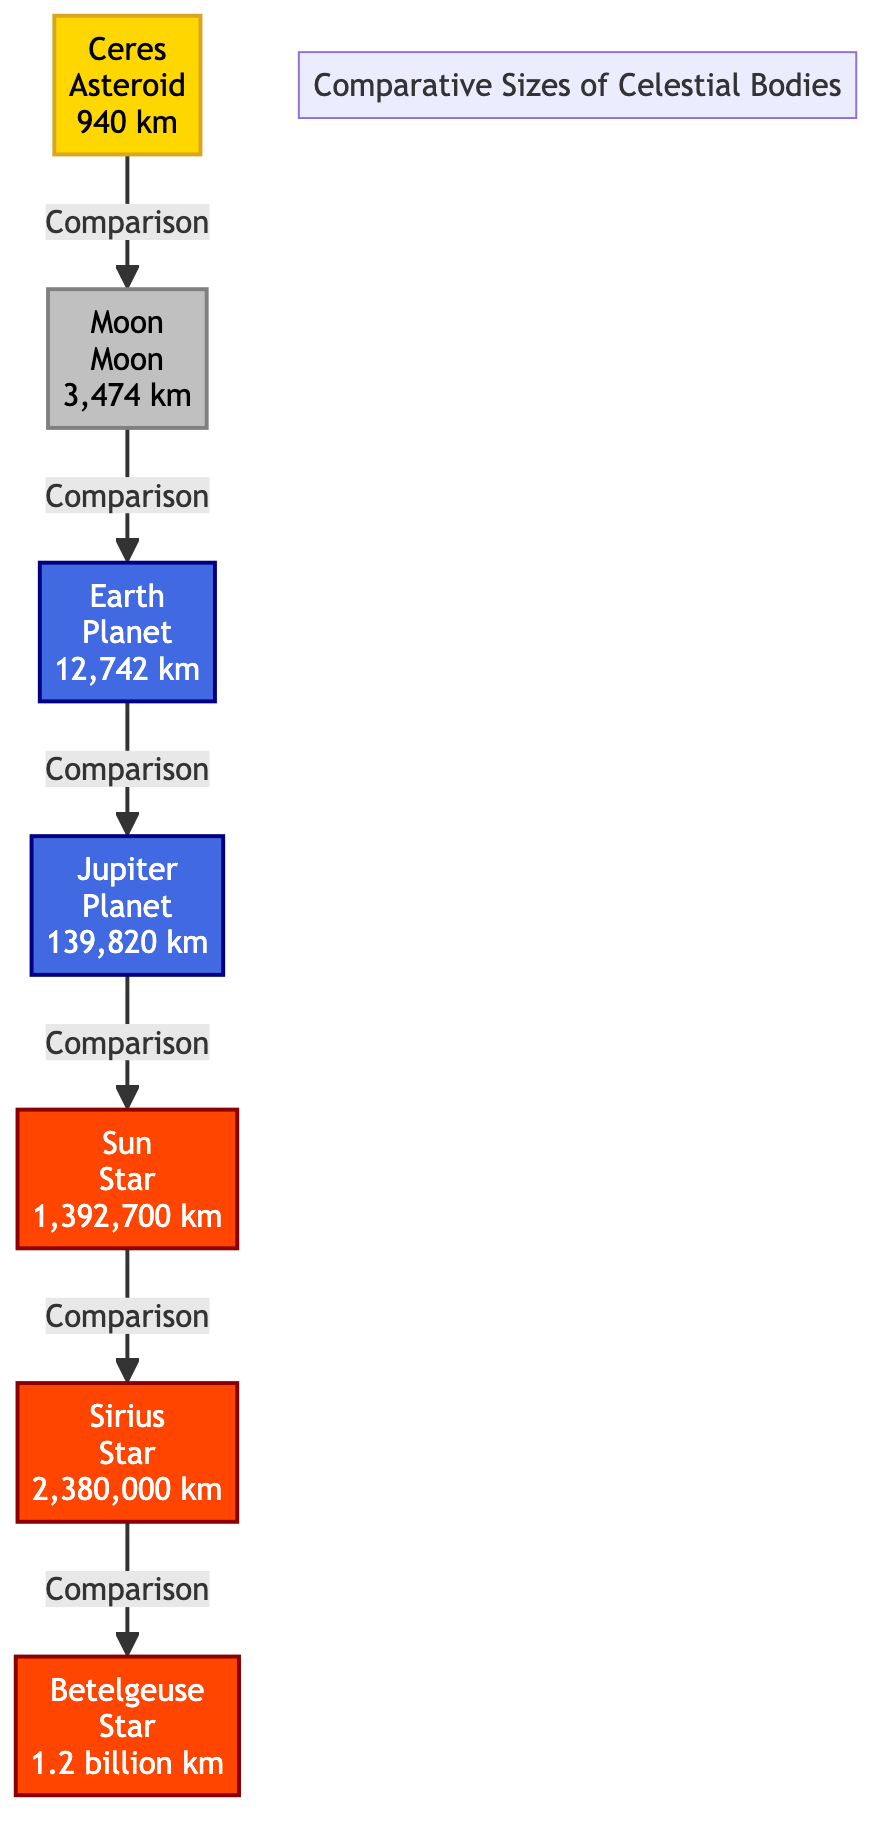What is the diameter of Ceres? The diagram states that Ceres is an asteroid with a diameter of 940 km. Therefore, the diameter is taken directly from the label associated with Ceres.
Answer: 940 km How many nodes are in the diagram? The diagram contains a total of 7 celestial bodies displayed as nodes: Ceres, Moon, Earth, Jupiter, Sun, Sirius, and Betelgeuse. This count is derived by simply listing all distinct items displayed in the diagram.
Answer: 7 Which celestial body is larger: Jupiter or Earth? The diagram shows that Jupiter has a diameter of 139,820 km while Earth has a diameter of 12,742 km. This comparison indicates which body is larger by directly comparing their values presented in the diagram.
Answer: Jupiter What is the diameter of Betelgeuse? According to the diagram, Betelgeuse is labeled with a diameter of 1.2 billion km (1,200,000,000 km). This value is taken directly from the information associated with Betelgeuse.
Answer: 1.2 billion km How many celestial bodies are classified as stars in the diagram? The diagram includes three celestial bodies classified as stars: the Sun, Sirius, and Betelgeuse. This count can be determined by identifying and counting the nodes specifically labeled as stars within the diagram.
Answer: 3 Which celestial body has the smallest diameter? The diagram indicates that Ceres, with a diameter of 940 km, is the smallest celestial body in comparison to the Moon, Earth, Jupiter, Sun, Sirius, and Betelgeuse, by checking the diameters presented for each.
Answer: Ceres What is the relationship between the Moon and Earth in the diagram? The diagram illustrates that the Moon is compared to Earth, which indicates a direct connection and relational aspect where the two celestial bodies are assessed against each other in size.
Answer: Comparison Which celestial body is the largest according to the diagram? The diagram indicates that Betelgeuse has a diameter of 1.2 billion km, which is larger than all other celestial bodies presented. Thus, the largest body can be determined directly from the sizes provided.
Answer: Betelgeuse 